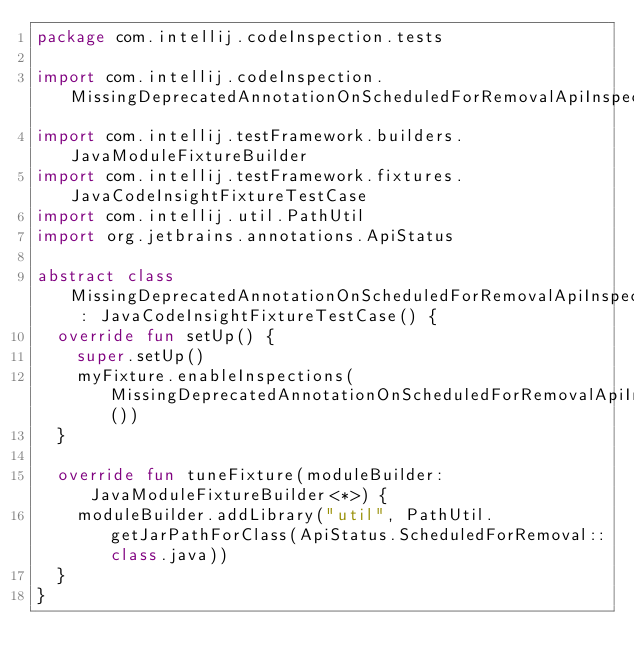Convert code to text. <code><loc_0><loc_0><loc_500><loc_500><_Kotlin_>package com.intellij.codeInspection.tests

import com.intellij.codeInspection.MissingDeprecatedAnnotationOnScheduledForRemovalApiInspection
import com.intellij.testFramework.builders.JavaModuleFixtureBuilder
import com.intellij.testFramework.fixtures.JavaCodeInsightFixtureTestCase
import com.intellij.util.PathUtil
import org.jetbrains.annotations.ApiStatus

abstract class MissingDeprecatedAnnotationOnScheduledForRemovalApiInspectionTestBase : JavaCodeInsightFixtureTestCase() {
  override fun setUp() {
    super.setUp()
    myFixture.enableInspections(MissingDeprecatedAnnotationOnScheduledForRemovalApiInspection())
  }

  override fun tuneFixture(moduleBuilder: JavaModuleFixtureBuilder<*>) {
    moduleBuilder.addLibrary("util", PathUtil.getJarPathForClass(ApiStatus.ScheduledForRemoval::class.java))
  }
}</code> 